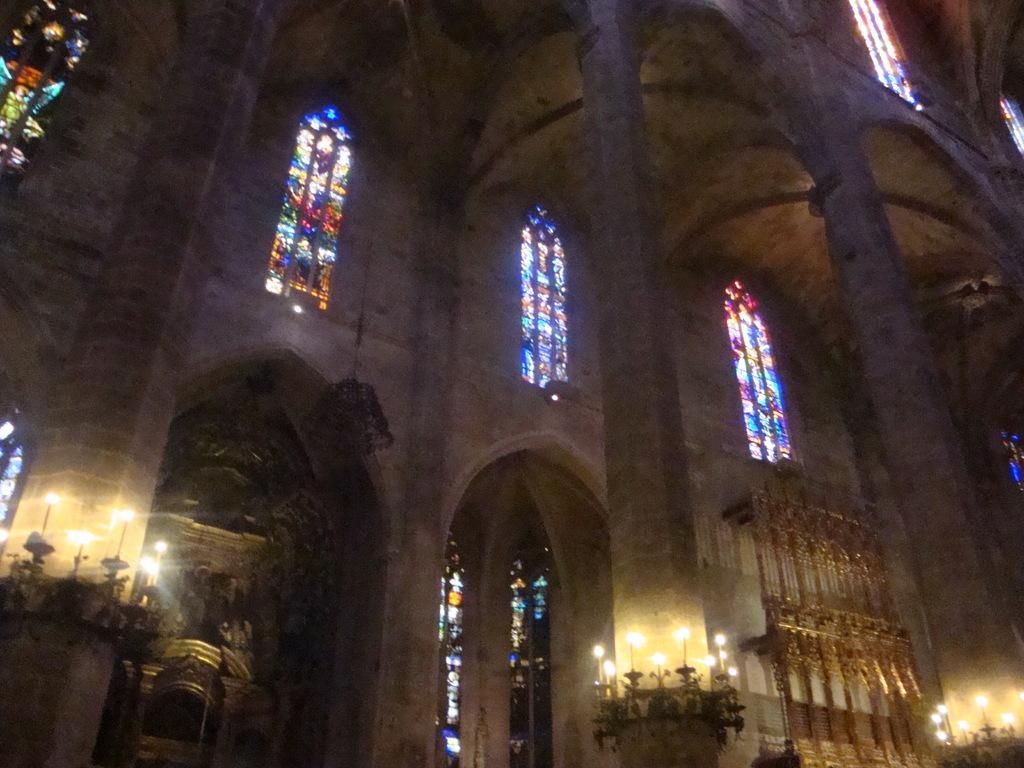In one or two sentences, can you explain what this image depicts? This is an image clicked in the dark. Here I can see a building. There are some windows and pillars. At the bottom of the pillars there are some candles. 